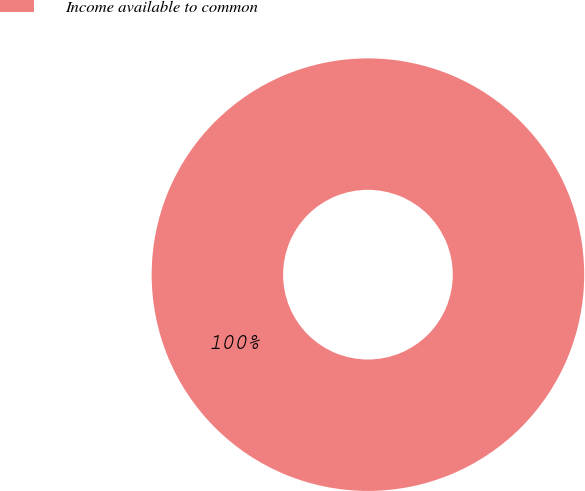<chart> <loc_0><loc_0><loc_500><loc_500><pie_chart><fcel>Income available to common<nl><fcel>100.0%<nl></chart> 